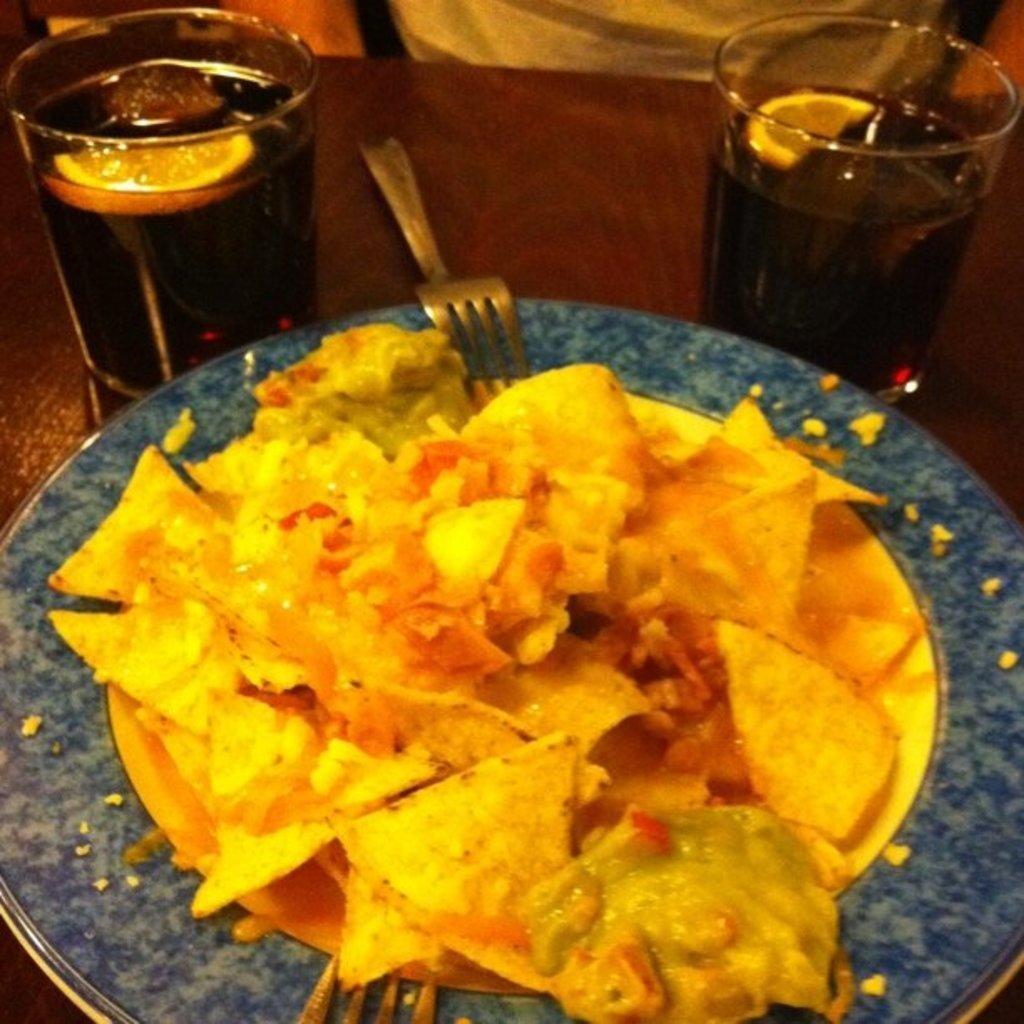Can you describe this image briefly? Here in this picture we can see a table, on which we can see a plate of food and a couple of fork spoons and a couple of glasses of cool drinks present on it over there. 